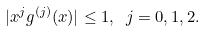Convert formula to latex. <formula><loc_0><loc_0><loc_500><loc_500>| x ^ { j } g ^ { ( j ) } ( x ) | \leq 1 , \ j = 0 , 1 , 2 .</formula> 